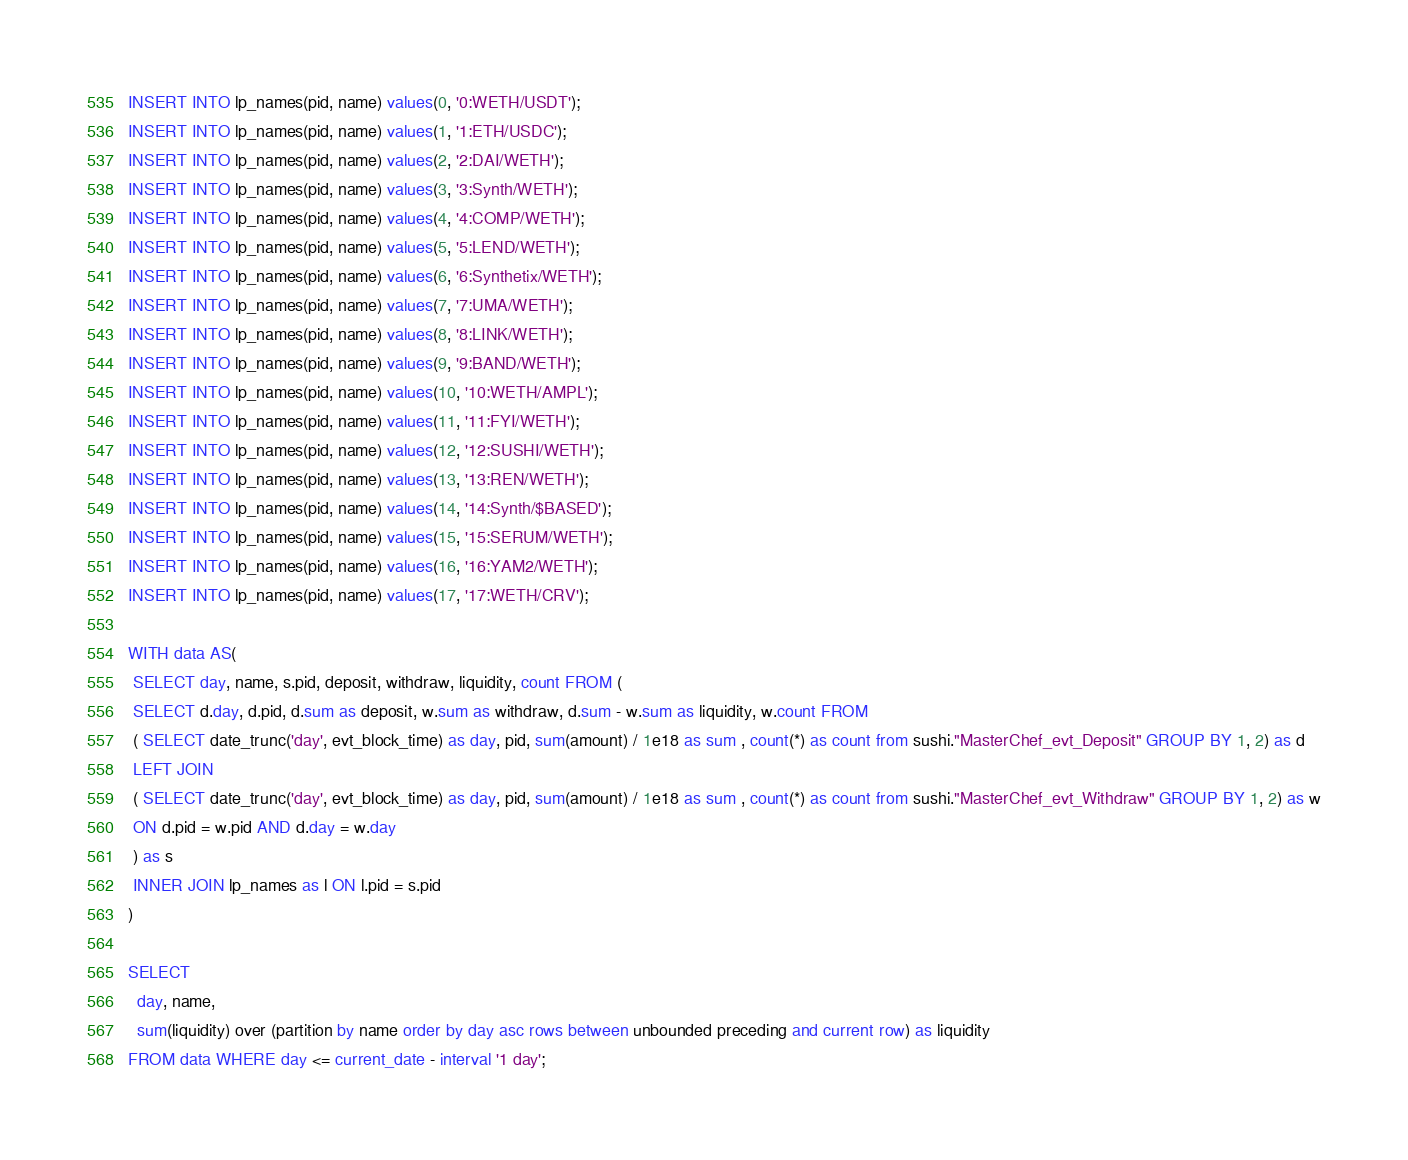<code> <loc_0><loc_0><loc_500><loc_500><_SQL_>INSERT INTO lp_names(pid, name) values(0, '0:WETH/USDT');
INSERT INTO lp_names(pid, name) values(1, '1:ETH/USDC');
INSERT INTO lp_names(pid, name) values(2, '2:DAI/WETH');
INSERT INTO lp_names(pid, name) values(3, '3:Synth/WETH');
INSERT INTO lp_names(pid, name) values(4, '4:COMP/WETH');
INSERT INTO lp_names(pid, name) values(5, '5:LEND/WETH');
INSERT INTO lp_names(pid, name) values(6, '6:Synthetix/WETH');
INSERT INTO lp_names(pid, name) values(7, '7:UMA/WETH');
INSERT INTO lp_names(pid, name) values(8, '8:LINK/WETH');
INSERT INTO lp_names(pid, name) values(9, '9:BAND/WETH');
INSERT INTO lp_names(pid, name) values(10, '10:WETH/AMPL');
INSERT INTO lp_names(pid, name) values(11, '11:FYI/WETH');
INSERT INTO lp_names(pid, name) values(12, '12:SUSHI/WETH');
INSERT INTO lp_names(pid, name) values(13, '13:REN/WETH');
INSERT INTO lp_names(pid, name) values(14, '14:Synth/$BASED');
INSERT INTO lp_names(pid, name) values(15, '15:SERUM/WETH');
INSERT INTO lp_names(pid, name) values(16, '16:YAM2/WETH');
INSERT INTO lp_names(pid, name) values(17, '17:WETH/CRV');

WITH data AS(
 SELECT day, name, s.pid, deposit, withdraw, liquidity, count FROM (
 SELECT d.day, d.pid, d.sum as deposit, w.sum as withdraw, d.sum - w.sum as liquidity, w.count FROM
 ( SELECT date_trunc('day', evt_block_time) as day, pid, sum(amount) / 1e18 as sum , count(*) as count from sushi."MasterChef_evt_Deposit" GROUP BY 1, 2) as d
 LEFT JOIN
 ( SELECT date_trunc('day', evt_block_time) as day, pid, sum(amount) / 1e18 as sum , count(*) as count from sushi."MasterChef_evt_Withdraw" GROUP BY 1, 2) as w
 ON d.pid = w.pid AND d.day = w.day
 ) as s
 INNER JOIN lp_names as l ON l.pid = s.pid
)

SELECT
  day, name,
  sum(liquidity) over (partition by name order by day asc rows between unbounded preceding and current row) as liquidity
FROM data WHERE day <= current_date - interval '1 day';
</code> 